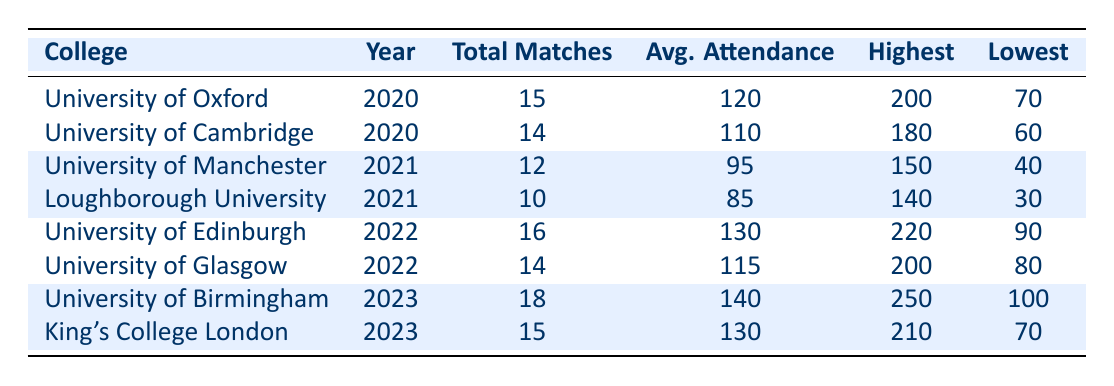What college had the highest average attendance in 2023? The only two colleges listed for 2023 are the University of Birmingham with an average attendance of 140 and King's College London with an average attendance of 130. Comparing these values, the University of Birmingham had the highest average attendance.
Answer: University of Birmingham How many total matches were played by the University of Oxford in 2020? The table shows that the University of Oxford played a total of 15 matches in 2020.
Answer: 15 What is the difference in highest attendance between the University of Edinburgh in 2022 and the University of Birmingham in 2023? The highest attendance for the University of Edinburgh in 2022 was 220, while for the University of Birmingham in 2023, it was 250. To find the difference, subtract 220 from 250, which equals 30.
Answer: 30 Did Loughborough University have more total matches in 2021 than the University of Edinburgh in 2022? Loughborough University played 10 matches in 2021 and the University of Edinburgh played 16 matches in 2022. Since 10 is less than 16, the answer is no.
Answer: No What is the average attendance across all years for the University of Cambridge? The only data available for the University of Cambridge is from 2020, where the average attendance was 110. Since there are no other years of data, the average attendance is simply 110.
Answer: 110 Which college had the lowest attendance for a match and what was that attendance? The lowest attendance recorded for a match was for Loughborough University in 2021 at 30. This is clearly mentioned in the table for that entry.
Answer: 30 How many colleges had an average attendance of more than 120 from 2020 to 2023? The colleges with average attendance greater than 120 are the University of Edinburgh (130), University of Birmingham (140), and University of Oxford (120). Therefore, there are three colleges.
Answer: 3 What is the average total attendance for all matches played by King's College London? King's College London has only one entry for 2023 with an average attendance of 130. Since there are no other data points, this average stands alone as 130.
Answer: 130 